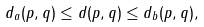<formula> <loc_0><loc_0><loc_500><loc_500>d _ { a } ( p , q ) \leq d ( p , q ) \leq d _ { b } ( p , q ) ,</formula> 